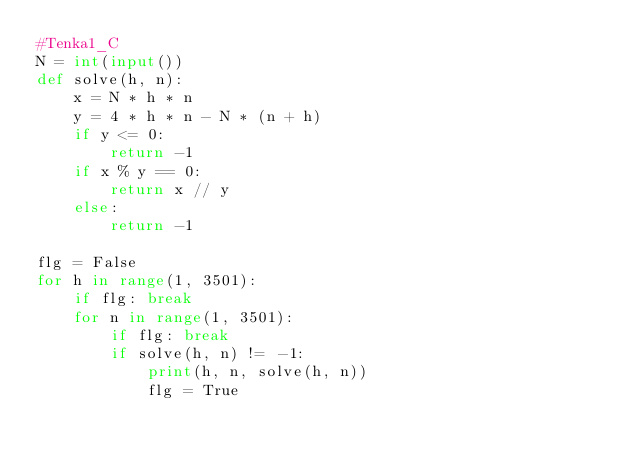Convert code to text. <code><loc_0><loc_0><loc_500><loc_500><_Python_>#Tenka1_C
N = int(input())
def solve(h, n):
    x = N * h * n
    y = 4 * h * n - N * (n + h)
    if y <= 0:
        return -1
    if x % y == 0:
        return x // y
    else:
        return -1
    
flg = False
for h in range(1, 3501):
    if flg: break
    for n in range(1, 3501):
        if flg: break
        if solve(h, n) != -1:
            print(h, n, solve(h, n))
            flg = True</code> 